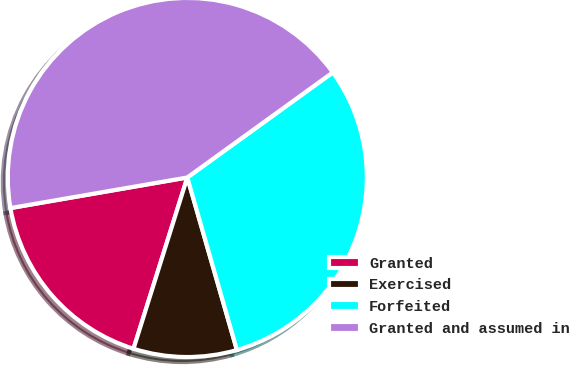Convert chart. <chart><loc_0><loc_0><loc_500><loc_500><pie_chart><fcel>Granted<fcel>Exercised<fcel>Forfeited<fcel>Granted and assumed in<nl><fcel>17.43%<fcel>9.3%<fcel>30.5%<fcel>42.77%<nl></chart> 